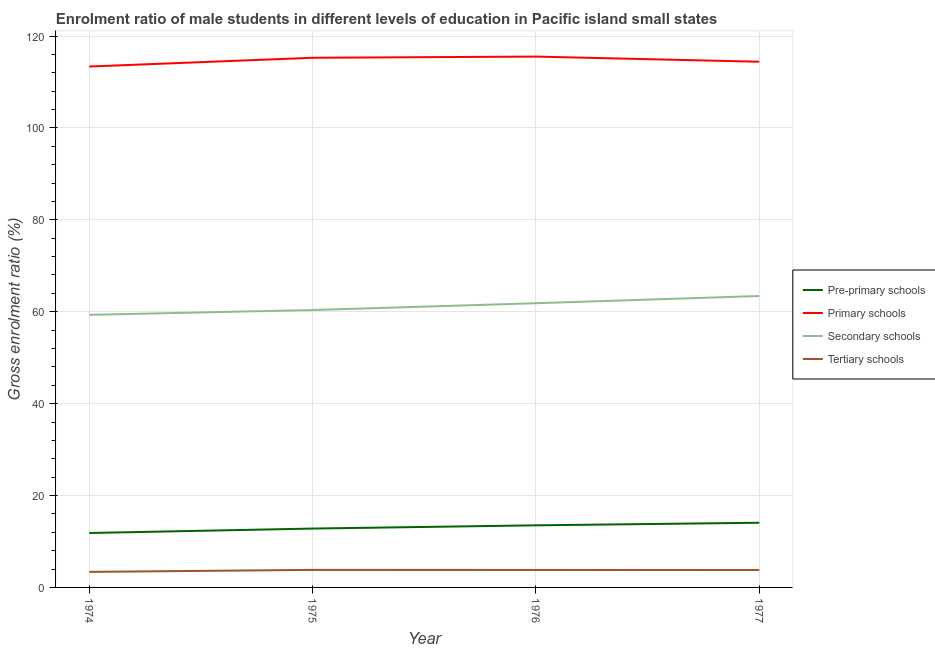How many different coloured lines are there?
Provide a succinct answer. 4. What is the gross enrolment ratio(female) in pre-primary schools in 1977?
Offer a terse response. 14.07. Across all years, what is the maximum gross enrolment ratio(female) in tertiary schools?
Offer a terse response. 3.82. Across all years, what is the minimum gross enrolment ratio(female) in pre-primary schools?
Offer a very short reply. 11.84. In which year was the gross enrolment ratio(female) in primary schools maximum?
Give a very brief answer. 1976. In which year was the gross enrolment ratio(female) in tertiary schools minimum?
Provide a short and direct response. 1974. What is the total gross enrolment ratio(female) in tertiary schools in the graph?
Ensure brevity in your answer.  14.8. What is the difference between the gross enrolment ratio(female) in secondary schools in 1974 and that in 1977?
Offer a terse response. -4.1. What is the difference between the gross enrolment ratio(female) in secondary schools in 1975 and the gross enrolment ratio(female) in tertiary schools in 1974?
Keep it short and to the point. 56.99. What is the average gross enrolment ratio(female) in secondary schools per year?
Make the answer very short. 61.24. In the year 1977, what is the difference between the gross enrolment ratio(female) in pre-primary schools and gross enrolment ratio(female) in primary schools?
Your answer should be compact. -100.33. What is the ratio of the gross enrolment ratio(female) in tertiary schools in 1975 to that in 1976?
Offer a terse response. 1. What is the difference between the highest and the second highest gross enrolment ratio(female) in pre-primary schools?
Provide a succinct answer. 0.56. What is the difference between the highest and the lowest gross enrolment ratio(female) in secondary schools?
Your answer should be compact. 4.1. Is the sum of the gross enrolment ratio(female) in tertiary schools in 1976 and 1977 greater than the maximum gross enrolment ratio(female) in pre-primary schools across all years?
Your answer should be compact. No. Is the gross enrolment ratio(female) in secondary schools strictly greater than the gross enrolment ratio(female) in tertiary schools over the years?
Provide a short and direct response. Yes. Is the gross enrolment ratio(female) in secondary schools strictly less than the gross enrolment ratio(female) in pre-primary schools over the years?
Provide a succinct answer. No. Are the values on the major ticks of Y-axis written in scientific E-notation?
Keep it short and to the point. No. Does the graph contain grids?
Ensure brevity in your answer.  Yes. How many legend labels are there?
Ensure brevity in your answer.  4. How are the legend labels stacked?
Keep it short and to the point. Vertical. What is the title of the graph?
Offer a terse response. Enrolment ratio of male students in different levels of education in Pacific island small states. Does "Corruption" appear as one of the legend labels in the graph?
Make the answer very short. No. What is the label or title of the X-axis?
Make the answer very short. Year. What is the Gross enrolment ratio (%) in Pre-primary schools in 1974?
Make the answer very short. 11.84. What is the Gross enrolment ratio (%) in Primary schools in 1974?
Your answer should be very brief. 113.36. What is the Gross enrolment ratio (%) of Secondary schools in 1974?
Make the answer very short. 59.32. What is the Gross enrolment ratio (%) of Tertiary schools in 1974?
Ensure brevity in your answer.  3.38. What is the Gross enrolment ratio (%) in Pre-primary schools in 1975?
Give a very brief answer. 12.81. What is the Gross enrolment ratio (%) in Primary schools in 1975?
Ensure brevity in your answer.  115.27. What is the Gross enrolment ratio (%) in Secondary schools in 1975?
Ensure brevity in your answer.  60.37. What is the Gross enrolment ratio (%) in Tertiary schools in 1975?
Offer a terse response. 3.82. What is the Gross enrolment ratio (%) of Pre-primary schools in 1976?
Your answer should be very brief. 13.52. What is the Gross enrolment ratio (%) of Primary schools in 1976?
Offer a very short reply. 115.53. What is the Gross enrolment ratio (%) in Secondary schools in 1976?
Keep it short and to the point. 61.85. What is the Gross enrolment ratio (%) of Tertiary schools in 1976?
Your answer should be very brief. 3.8. What is the Gross enrolment ratio (%) of Pre-primary schools in 1977?
Provide a short and direct response. 14.07. What is the Gross enrolment ratio (%) in Primary schools in 1977?
Ensure brevity in your answer.  114.41. What is the Gross enrolment ratio (%) of Secondary schools in 1977?
Offer a terse response. 63.42. What is the Gross enrolment ratio (%) in Tertiary schools in 1977?
Your response must be concise. 3.8. Across all years, what is the maximum Gross enrolment ratio (%) of Pre-primary schools?
Your answer should be compact. 14.07. Across all years, what is the maximum Gross enrolment ratio (%) in Primary schools?
Your answer should be compact. 115.53. Across all years, what is the maximum Gross enrolment ratio (%) of Secondary schools?
Your answer should be compact. 63.42. Across all years, what is the maximum Gross enrolment ratio (%) of Tertiary schools?
Ensure brevity in your answer.  3.82. Across all years, what is the minimum Gross enrolment ratio (%) in Pre-primary schools?
Offer a very short reply. 11.84. Across all years, what is the minimum Gross enrolment ratio (%) in Primary schools?
Give a very brief answer. 113.36. Across all years, what is the minimum Gross enrolment ratio (%) of Secondary schools?
Give a very brief answer. 59.32. Across all years, what is the minimum Gross enrolment ratio (%) in Tertiary schools?
Your answer should be very brief. 3.38. What is the total Gross enrolment ratio (%) in Pre-primary schools in the graph?
Provide a short and direct response. 52.24. What is the total Gross enrolment ratio (%) in Primary schools in the graph?
Your response must be concise. 458.56. What is the total Gross enrolment ratio (%) in Secondary schools in the graph?
Give a very brief answer. 244.97. What is the total Gross enrolment ratio (%) of Tertiary schools in the graph?
Offer a very short reply. 14.8. What is the difference between the Gross enrolment ratio (%) in Pre-primary schools in 1974 and that in 1975?
Your response must be concise. -0.96. What is the difference between the Gross enrolment ratio (%) of Primary schools in 1974 and that in 1975?
Offer a very short reply. -1.91. What is the difference between the Gross enrolment ratio (%) of Secondary schools in 1974 and that in 1975?
Your answer should be compact. -1.05. What is the difference between the Gross enrolment ratio (%) of Tertiary schools in 1974 and that in 1975?
Provide a short and direct response. -0.44. What is the difference between the Gross enrolment ratio (%) in Pre-primary schools in 1974 and that in 1976?
Keep it short and to the point. -1.67. What is the difference between the Gross enrolment ratio (%) in Primary schools in 1974 and that in 1976?
Offer a terse response. -2.16. What is the difference between the Gross enrolment ratio (%) of Secondary schools in 1974 and that in 1976?
Make the answer very short. -2.53. What is the difference between the Gross enrolment ratio (%) in Tertiary schools in 1974 and that in 1976?
Provide a succinct answer. -0.42. What is the difference between the Gross enrolment ratio (%) of Pre-primary schools in 1974 and that in 1977?
Your answer should be very brief. -2.23. What is the difference between the Gross enrolment ratio (%) in Primary schools in 1974 and that in 1977?
Offer a very short reply. -1.04. What is the difference between the Gross enrolment ratio (%) in Secondary schools in 1974 and that in 1977?
Keep it short and to the point. -4.1. What is the difference between the Gross enrolment ratio (%) in Tertiary schools in 1974 and that in 1977?
Your answer should be very brief. -0.41. What is the difference between the Gross enrolment ratio (%) of Pre-primary schools in 1975 and that in 1976?
Give a very brief answer. -0.71. What is the difference between the Gross enrolment ratio (%) of Primary schools in 1975 and that in 1976?
Make the answer very short. -0.26. What is the difference between the Gross enrolment ratio (%) in Secondary schools in 1975 and that in 1976?
Keep it short and to the point. -1.48. What is the difference between the Gross enrolment ratio (%) in Tertiary schools in 1975 and that in 1976?
Your response must be concise. 0.02. What is the difference between the Gross enrolment ratio (%) of Pre-primary schools in 1975 and that in 1977?
Give a very brief answer. -1.26. What is the difference between the Gross enrolment ratio (%) in Primary schools in 1975 and that in 1977?
Make the answer very short. 0.86. What is the difference between the Gross enrolment ratio (%) in Secondary schools in 1975 and that in 1977?
Make the answer very short. -3.05. What is the difference between the Gross enrolment ratio (%) in Tertiary schools in 1975 and that in 1977?
Offer a terse response. 0.02. What is the difference between the Gross enrolment ratio (%) in Pre-primary schools in 1976 and that in 1977?
Make the answer very short. -0.56. What is the difference between the Gross enrolment ratio (%) in Primary schools in 1976 and that in 1977?
Make the answer very short. 1.12. What is the difference between the Gross enrolment ratio (%) in Secondary schools in 1976 and that in 1977?
Your answer should be compact. -1.57. What is the difference between the Gross enrolment ratio (%) of Tertiary schools in 1976 and that in 1977?
Provide a succinct answer. 0.01. What is the difference between the Gross enrolment ratio (%) in Pre-primary schools in 1974 and the Gross enrolment ratio (%) in Primary schools in 1975?
Give a very brief answer. -103.42. What is the difference between the Gross enrolment ratio (%) of Pre-primary schools in 1974 and the Gross enrolment ratio (%) of Secondary schools in 1975?
Keep it short and to the point. -48.52. What is the difference between the Gross enrolment ratio (%) of Pre-primary schools in 1974 and the Gross enrolment ratio (%) of Tertiary schools in 1975?
Your answer should be very brief. 8.02. What is the difference between the Gross enrolment ratio (%) of Primary schools in 1974 and the Gross enrolment ratio (%) of Secondary schools in 1975?
Make the answer very short. 52.99. What is the difference between the Gross enrolment ratio (%) of Primary schools in 1974 and the Gross enrolment ratio (%) of Tertiary schools in 1975?
Offer a very short reply. 109.54. What is the difference between the Gross enrolment ratio (%) of Secondary schools in 1974 and the Gross enrolment ratio (%) of Tertiary schools in 1975?
Give a very brief answer. 55.5. What is the difference between the Gross enrolment ratio (%) of Pre-primary schools in 1974 and the Gross enrolment ratio (%) of Primary schools in 1976?
Provide a short and direct response. -103.68. What is the difference between the Gross enrolment ratio (%) in Pre-primary schools in 1974 and the Gross enrolment ratio (%) in Secondary schools in 1976?
Ensure brevity in your answer.  -50.01. What is the difference between the Gross enrolment ratio (%) of Pre-primary schools in 1974 and the Gross enrolment ratio (%) of Tertiary schools in 1976?
Keep it short and to the point. 8.04. What is the difference between the Gross enrolment ratio (%) of Primary schools in 1974 and the Gross enrolment ratio (%) of Secondary schools in 1976?
Offer a terse response. 51.51. What is the difference between the Gross enrolment ratio (%) of Primary schools in 1974 and the Gross enrolment ratio (%) of Tertiary schools in 1976?
Offer a terse response. 109.56. What is the difference between the Gross enrolment ratio (%) in Secondary schools in 1974 and the Gross enrolment ratio (%) in Tertiary schools in 1976?
Your answer should be very brief. 55.52. What is the difference between the Gross enrolment ratio (%) of Pre-primary schools in 1974 and the Gross enrolment ratio (%) of Primary schools in 1977?
Your answer should be very brief. -102.56. What is the difference between the Gross enrolment ratio (%) of Pre-primary schools in 1974 and the Gross enrolment ratio (%) of Secondary schools in 1977?
Your answer should be very brief. -51.58. What is the difference between the Gross enrolment ratio (%) in Pre-primary schools in 1974 and the Gross enrolment ratio (%) in Tertiary schools in 1977?
Your response must be concise. 8.05. What is the difference between the Gross enrolment ratio (%) in Primary schools in 1974 and the Gross enrolment ratio (%) in Secondary schools in 1977?
Your answer should be very brief. 49.94. What is the difference between the Gross enrolment ratio (%) in Primary schools in 1974 and the Gross enrolment ratio (%) in Tertiary schools in 1977?
Provide a short and direct response. 109.56. What is the difference between the Gross enrolment ratio (%) in Secondary schools in 1974 and the Gross enrolment ratio (%) in Tertiary schools in 1977?
Your answer should be compact. 55.52. What is the difference between the Gross enrolment ratio (%) in Pre-primary schools in 1975 and the Gross enrolment ratio (%) in Primary schools in 1976?
Offer a very short reply. -102.72. What is the difference between the Gross enrolment ratio (%) in Pre-primary schools in 1975 and the Gross enrolment ratio (%) in Secondary schools in 1976?
Ensure brevity in your answer.  -49.04. What is the difference between the Gross enrolment ratio (%) in Pre-primary schools in 1975 and the Gross enrolment ratio (%) in Tertiary schools in 1976?
Your answer should be very brief. 9.01. What is the difference between the Gross enrolment ratio (%) of Primary schools in 1975 and the Gross enrolment ratio (%) of Secondary schools in 1976?
Offer a very short reply. 53.41. What is the difference between the Gross enrolment ratio (%) in Primary schools in 1975 and the Gross enrolment ratio (%) in Tertiary schools in 1976?
Offer a terse response. 111.46. What is the difference between the Gross enrolment ratio (%) in Secondary schools in 1975 and the Gross enrolment ratio (%) in Tertiary schools in 1976?
Your answer should be very brief. 56.56. What is the difference between the Gross enrolment ratio (%) in Pre-primary schools in 1975 and the Gross enrolment ratio (%) in Primary schools in 1977?
Your answer should be very brief. -101.6. What is the difference between the Gross enrolment ratio (%) in Pre-primary schools in 1975 and the Gross enrolment ratio (%) in Secondary schools in 1977?
Your response must be concise. -50.61. What is the difference between the Gross enrolment ratio (%) of Pre-primary schools in 1975 and the Gross enrolment ratio (%) of Tertiary schools in 1977?
Provide a succinct answer. 9.01. What is the difference between the Gross enrolment ratio (%) in Primary schools in 1975 and the Gross enrolment ratio (%) in Secondary schools in 1977?
Your answer should be compact. 51.85. What is the difference between the Gross enrolment ratio (%) of Primary schools in 1975 and the Gross enrolment ratio (%) of Tertiary schools in 1977?
Your response must be concise. 111.47. What is the difference between the Gross enrolment ratio (%) of Secondary schools in 1975 and the Gross enrolment ratio (%) of Tertiary schools in 1977?
Your answer should be compact. 56.57. What is the difference between the Gross enrolment ratio (%) in Pre-primary schools in 1976 and the Gross enrolment ratio (%) in Primary schools in 1977?
Keep it short and to the point. -100.89. What is the difference between the Gross enrolment ratio (%) of Pre-primary schools in 1976 and the Gross enrolment ratio (%) of Secondary schools in 1977?
Make the answer very short. -49.91. What is the difference between the Gross enrolment ratio (%) in Pre-primary schools in 1976 and the Gross enrolment ratio (%) in Tertiary schools in 1977?
Make the answer very short. 9.72. What is the difference between the Gross enrolment ratio (%) of Primary schools in 1976 and the Gross enrolment ratio (%) of Secondary schools in 1977?
Make the answer very short. 52.1. What is the difference between the Gross enrolment ratio (%) in Primary schools in 1976 and the Gross enrolment ratio (%) in Tertiary schools in 1977?
Ensure brevity in your answer.  111.73. What is the difference between the Gross enrolment ratio (%) in Secondary schools in 1976 and the Gross enrolment ratio (%) in Tertiary schools in 1977?
Offer a very short reply. 58.06. What is the average Gross enrolment ratio (%) of Pre-primary schools per year?
Ensure brevity in your answer.  13.06. What is the average Gross enrolment ratio (%) of Primary schools per year?
Offer a terse response. 114.64. What is the average Gross enrolment ratio (%) in Secondary schools per year?
Provide a succinct answer. 61.24. What is the average Gross enrolment ratio (%) in Tertiary schools per year?
Your answer should be compact. 3.7. In the year 1974, what is the difference between the Gross enrolment ratio (%) in Pre-primary schools and Gross enrolment ratio (%) in Primary schools?
Give a very brief answer. -101.52. In the year 1974, what is the difference between the Gross enrolment ratio (%) of Pre-primary schools and Gross enrolment ratio (%) of Secondary schools?
Make the answer very short. -47.48. In the year 1974, what is the difference between the Gross enrolment ratio (%) in Pre-primary schools and Gross enrolment ratio (%) in Tertiary schools?
Provide a succinct answer. 8.46. In the year 1974, what is the difference between the Gross enrolment ratio (%) of Primary schools and Gross enrolment ratio (%) of Secondary schools?
Your answer should be compact. 54.04. In the year 1974, what is the difference between the Gross enrolment ratio (%) in Primary schools and Gross enrolment ratio (%) in Tertiary schools?
Give a very brief answer. 109.98. In the year 1974, what is the difference between the Gross enrolment ratio (%) in Secondary schools and Gross enrolment ratio (%) in Tertiary schools?
Offer a terse response. 55.94. In the year 1975, what is the difference between the Gross enrolment ratio (%) in Pre-primary schools and Gross enrolment ratio (%) in Primary schools?
Keep it short and to the point. -102.46. In the year 1975, what is the difference between the Gross enrolment ratio (%) of Pre-primary schools and Gross enrolment ratio (%) of Secondary schools?
Offer a terse response. -47.56. In the year 1975, what is the difference between the Gross enrolment ratio (%) in Pre-primary schools and Gross enrolment ratio (%) in Tertiary schools?
Make the answer very short. 8.99. In the year 1975, what is the difference between the Gross enrolment ratio (%) of Primary schools and Gross enrolment ratio (%) of Secondary schools?
Your response must be concise. 54.9. In the year 1975, what is the difference between the Gross enrolment ratio (%) in Primary schools and Gross enrolment ratio (%) in Tertiary schools?
Keep it short and to the point. 111.45. In the year 1975, what is the difference between the Gross enrolment ratio (%) in Secondary schools and Gross enrolment ratio (%) in Tertiary schools?
Offer a very short reply. 56.55. In the year 1976, what is the difference between the Gross enrolment ratio (%) in Pre-primary schools and Gross enrolment ratio (%) in Primary schools?
Ensure brevity in your answer.  -102.01. In the year 1976, what is the difference between the Gross enrolment ratio (%) in Pre-primary schools and Gross enrolment ratio (%) in Secondary schools?
Your response must be concise. -48.34. In the year 1976, what is the difference between the Gross enrolment ratio (%) in Pre-primary schools and Gross enrolment ratio (%) in Tertiary schools?
Ensure brevity in your answer.  9.71. In the year 1976, what is the difference between the Gross enrolment ratio (%) in Primary schools and Gross enrolment ratio (%) in Secondary schools?
Your answer should be compact. 53.67. In the year 1976, what is the difference between the Gross enrolment ratio (%) of Primary schools and Gross enrolment ratio (%) of Tertiary schools?
Make the answer very short. 111.72. In the year 1976, what is the difference between the Gross enrolment ratio (%) in Secondary schools and Gross enrolment ratio (%) in Tertiary schools?
Give a very brief answer. 58.05. In the year 1977, what is the difference between the Gross enrolment ratio (%) in Pre-primary schools and Gross enrolment ratio (%) in Primary schools?
Your response must be concise. -100.33. In the year 1977, what is the difference between the Gross enrolment ratio (%) of Pre-primary schools and Gross enrolment ratio (%) of Secondary schools?
Ensure brevity in your answer.  -49.35. In the year 1977, what is the difference between the Gross enrolment ratio (%) of Pre-primary schools and Gross enrolment ratio (%) of Tertiary schools?
Your response must be concise. 10.28. In the year 1977, what is the difference between the Gross enrolment ratio (%) in Primary schools and Gross enrolment ratio (%) in Secondary schools?
Provide a succinct answer. 50.98. In the year 1977, what is the difference between the Gross enrolment ratio (%) in Primary schools and Gross enrolment ratio (%) in Tertiary schools?
Make the answer very short. 110.61. In the year 1977, what is the difference between the Gross enrolment ratio (%) in Secondary schools and Gross enrolment ratio (%) in Tertiary schools?
Your answer should be compact. 59.63. What is the ratio of the Gross enrolment ratio (%) in Pre-primary schools in 1974 to that in 1975?
Ensure brevity in your answer.  0.92. What is the ratio of the Gross enrolment ratio (%) in Primary schools in 1974 to that in 1975?
Offer a very short reply. 0.98. What is the ratio of the Gross enrolment ratio (%) of Secondary schools in 1974 to that in 1975?
Offer a terse response. 0.98. What is the ratio of the Gross enrolment ratio (%) of Tertiary schools in 1974 to that in 1975?
Provide a short and direct response. 0.89. What is the ratio of the Gross enrolment ratio (%) in Pre-primary schools in 1974 to that in 1976?
Your response must be concise. 0.88. What is the ratio of the Gross enrolment ratio (%) in Primary schools in 1974 to that in 1976?
Offer a very short reply. 0.98. What is the ratio of the Gross enrolment ratio (%) in Secondary schools in 1974 to that in 1976?
Ensure brevity in your answer.  0.96. What is the ratio of the Gross enrolment ratio (%) of Tertiary schools in 1974 to that in 1976?
Offer a very short reply. 0.89. What is the ratio of the Gross enrolment ratio (%) in Pre-primary schools in 1974 to that in 1977?
Your response must be concise. 0.84. What is the ratio of the Gross enrolment ratio (%) of Primary schools in 1974 to that in 1977?
Ensure brevity in your answer.  0.99. What is the ratio of the Gross enrolment ratio (%) of Secondary schools in 1974 to that in 1977?
Provide a succinct answer. 0.94. What is the ratio of the Gross enrolment ratio (%) in Tertiary schools in 1974 to that in 1977?
Provide a short and direct response. 0.89. What is the ratio of the Gross enrolment ratio (%) in Pre-primary schools in 1975 to that in 1976?
Make the answer very short. 0.95. What is the ratio of the Gross enrolment ratio (%) in Tertiary schools in 1975 to that in 1976?
Your response must be concise. 1. What is the ratio of the Gross enrolment ratio (%) in Pre-primary schools in 1975 to that in 1977?
Provide a short and direct response. 0.91. What is the ratio of the Gross enrolment ratio (%) of Primary schools in 1975 to that in 1977?
Your response must be concise. 1.01. What is the ratio of the Gross enrolment ratio (%) in Secondary schools in 1975 to that in 1977?
Provide a short and direct response. 0.95. What is the ratio of the Gross enrolment ratio (%) in Pre-primary schools in 1976 to that in 1977?
Your response must be concise. 0.96. What is the ratio of the Gross enrolment ratio (%) of Primary schools in 1976 to that in 1977?
Your response must be concise. 1.01. What is the ratio of the Gross enrolment ratio (%) of Secondary schools in 1976 to that in 1977?
Make the answer very short. 0.98. What is the difference between the highest and the second highest Gross enrolment ratio (%) of Pre-primary schools?
Offer a terse response. 0.56. What is the difference between the highest and the second highest Gross enrolment ratio (%) of Primary schools?
Give a very brief answer. 0.26. What is the difference between the highest and the second highest Gross enrolment ratio (%) in Secondary schools?
Your answer should be compact. 1.57. What is the difference between the highest and the second highest Gross enrolment ratio (%) in Tertiary schools?
Your response must be concise. 0.02. What is the difference between the highest and the lowest Gross enrolment ratio (%) in Pre-primary schools?
Provide a short and direct response. 2.23. What is the difference between the highest and the lowest Gross enrolment ratio (%) of Primary schools?
Ensure brevity in your answer.  2.16. What is the difference between the highest and the lowest Gross enrolment ratio (%) in Secondary schools?
Your answer should be compact. 4.1. What is the difference between the highest and the lowest Gross enrolment ratio (%) of Tertiary schools?
Your response must be concise. 0.44. 